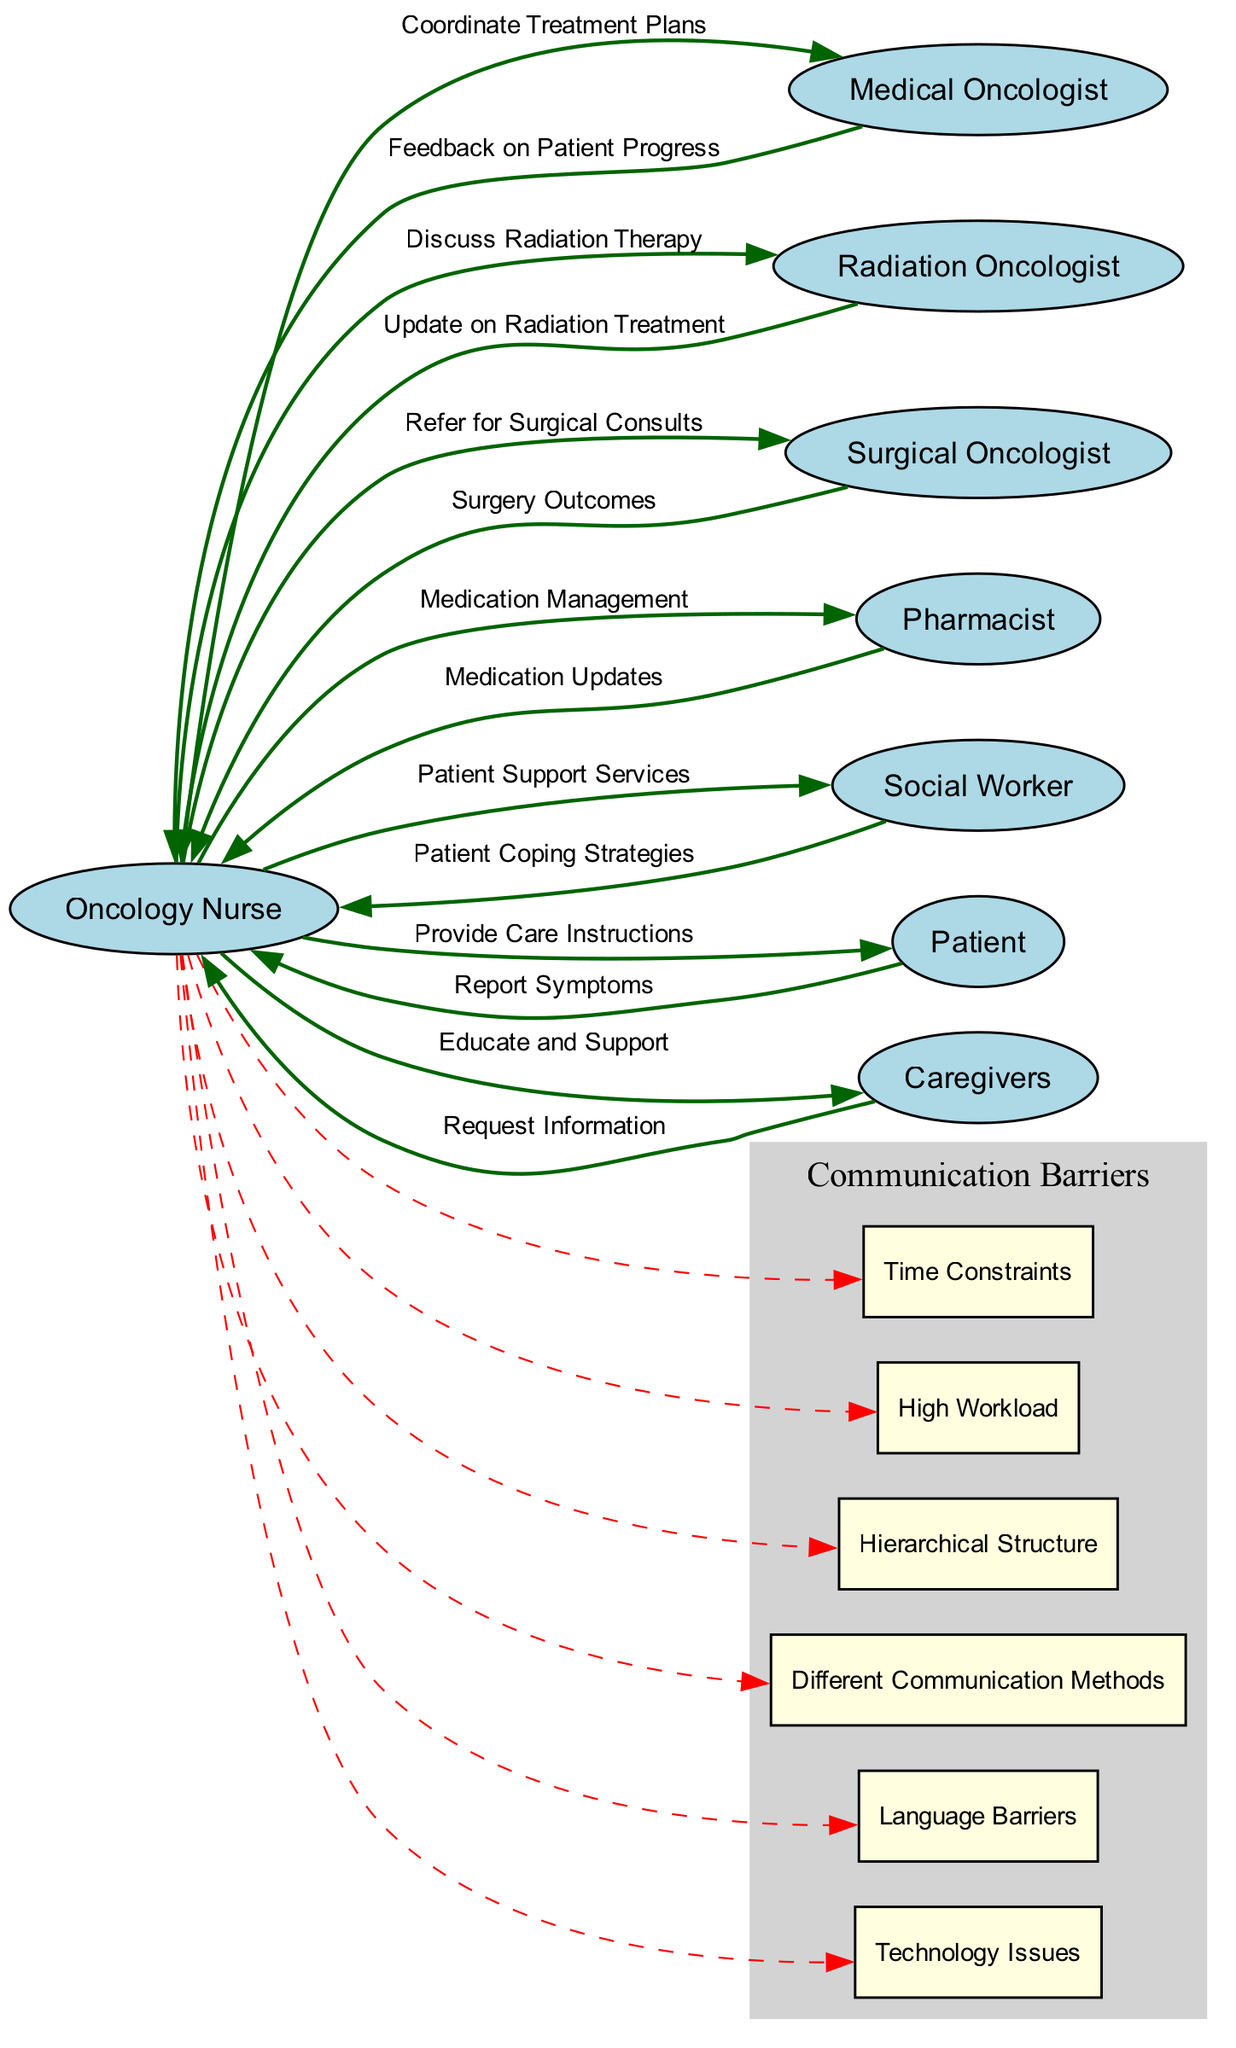What is the total number of nodes in the diagram? The diagram includes eight nodes representing different roles in the oncology clinic, including the oncology nurse, medical oncologist, radiation oncologist, surgical oncologist, pharmacist, social worker, patient, and caregivers. Counting these, we find a total of eight nodes.
Answer: 8 What is the connection label between the oncology nurse and the medical oncologist? The label describing the connection between the oncology nurse and the medical oncologist is "Coordinate Treatment Plans." This is derived directly from the edge that connects these two nodes in the diagram.
Answer: Coordinate Treatment Plans Which barrier is linked to the oncology nurse with a dashed line? The barriers are linked to the oncology nurse with dashed lines representing various challenges. One example of a barrier linked in this way is "Time Constraints," which more specifically shows the difficulties the oncology nurse faces in communication.
Answer: Time Constraints How many edges are there connecting the oncology nurse with other professionals? There are six edges that represent the communication and coordination duties between the oncology nurse and other healthcare professionals, such as medical oncologist, radiation oncologist, surgical oncologist, pharmacist, social worker, patient, and caregivers. Counting these edges, we find there are six.
Answer: 6 What type of structure is represented by the barrier labeled "Hierarchy"? The barrier labeled "Hierarchy" suggests an organizational or power structure that may affect communication dynamics. It denotes a hierarchy that might create challenges in information flow or decision-making processes between roles. This structure often leads to communication barriers due to positional authority.
Answer: Hierarchical Structure Which healthcare professional provides feedback to the oncology nurse? Feedback is provided to the oncology nurse by the medical oncologist. This relationship highlights the importance of communication concerning patient progress and treatment outcomes, which is depicted in the diagram through directed edges between these roles.
Answer: Medical Oncologist What are the common barriers identified in the communication flow? The common barriers identified include "Time Constraints," "High Workload," "Hierarchical Structure," "Different Communication Methods," "Language Barriers," and "Technology Issues." These barriers illustrate various challenges that can impede effective communication in the oncology clinic.
Answer: Time Constraints, High Workload, Hierarchical Structure, Different Communication Methods, Language Barriers, Technology Issues How many professionals are directly connected to the oncology nurse in terms of communication? The oncology nurse is directly connected to six other professionals, including medical oncologist, radiation oncologist, surgical oncologist, pharmacist, social worker, and caregivers, through communication edges. Thus, the answer reflects the connectivity of the oncology nurse within the multidisciplinary team.
Answer: 6 